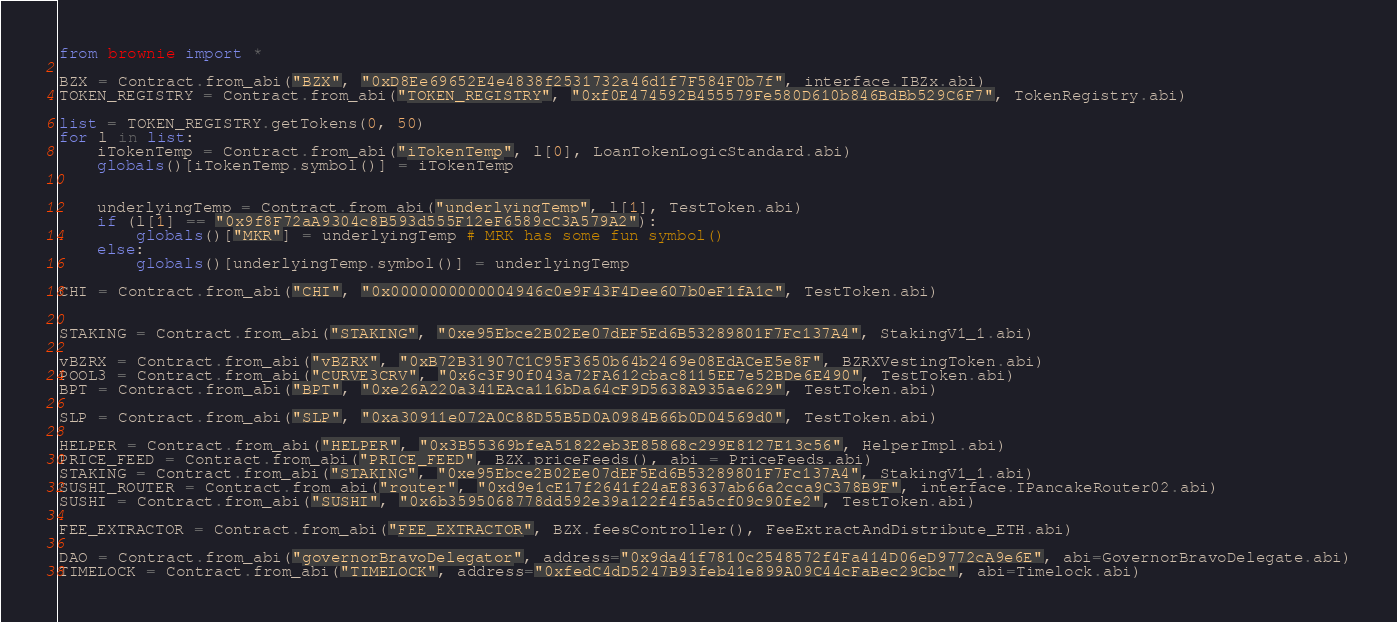<code> <loc_0><loc_0><loc_500><loc_500><_Python_>from brownie import *

BZX = Contract.from_abi("BZX", "0xD8Ee69652E4e4838f2531732a46d1f7F584F0b7f", interface.IBZx.abi)
TOKEN_REGISTRY = Contract.from_abi("TOKEN_REGISTRY", "0xf0E474592B455579Fe580D610b846BdBb529C6F7", TokenRegistry.abi)

list = TOKEN_REGISTRY.getTokens(0, 50)
for l in list:
    iTokenTemp = Contract.from_abi("iTokenTemp", l[0], LoanTokenLogicStandard.abi)
    globals()[iTokenTemp.symbol()] = iTokenTemp


    underlyingTemp = Contract.from_abi("underlyingTemp", l[1], TestToken.abi)
    if (l[1] == "0x9f8F72aA9304c8B593d555F12eF6589cC3A579A2"):
        globals()["MKR"] = underlyingTemp # MRK has some fun symbol()
    else:
        globals()[underlyingTemp.symbol()] = underlyingTemp

CHI = Contract.from_abi("CHI", "0x0000000000004946c0e9F43F4Dee607b0eF1fA1c", TestToken.abi)


STAKING = Contract.from_abi("STAKING", "0xe95Ebce2B02Ee07dEF5Ed6B53289801F7Fc137A4", StakingV1_1.abi)

vBZRX = Contract.from_abi("vBZRX", "0xB72B31907C1C95F3650b64b2469e08EdACeE5e8F", BZRXVestingToken.abi)
POOL3 = Contract.from_abi("CURVE3CRV", "0x6c3F90f043a72FA612cbac8115EE7e52BDe6E490", TestToken.abi)
BPT = Contract.from_abi("BPT", "0xe26A220a341EAca116bDa64cF9D5638A935ae629", TestToken.abi)

SLP = Contract.from_abi("SLP", "0xa30911e072A0C88D55B5D0A0984B66b0D04569d0", TestToken.abi)

HELPER = Contract.from_abi("HELPER", "0x3B55369bfeA51822eb3E85868c299E8127E13c56", HelperImpl.abi)
PRICE_FEED = Contract.from_abi("PRICE_FEED", BZX.priceFeeds(), abi = PriceFeeds.abi)
STAKING = Contract.from_abi("STAKING", "0xe95Ebce2B02Ee07dEF5Ed6B53289801F7Fc137A4", StakingV1_1.abi)
SUSHI_ROUTER = Contract.from_abi("router", "0xd9e1cE17f2641f24aE83637ab66a2cca9C378B9F", interface.IPancakeRouter02.abi)
SUSHI = Contract.from_abi("SUSHI", "0x6b3595068778dd592e39a122f4f5a5cf09c90fe2", TestToken.abi)

FEE_EXTRACTOR = Contract.from_abi("FEE_EXTRACTOR", BZX.feesController(), FeeExtractAndDistribute_ETH.abi)

DAO = Contract.from_abi("governorBravoDelegator", address="0x9da41f7810c2548572f4Fa414D06eD9772cA9e6E", abi=GovernorBravoDelegate.abi)
TIMELOCK = Contract.from_abi("TIMELOCK", address="0xfedC4dD5247B93feb41e899A09C44cFaBec29Cbc", abi=Timelock.abi)

</code> 